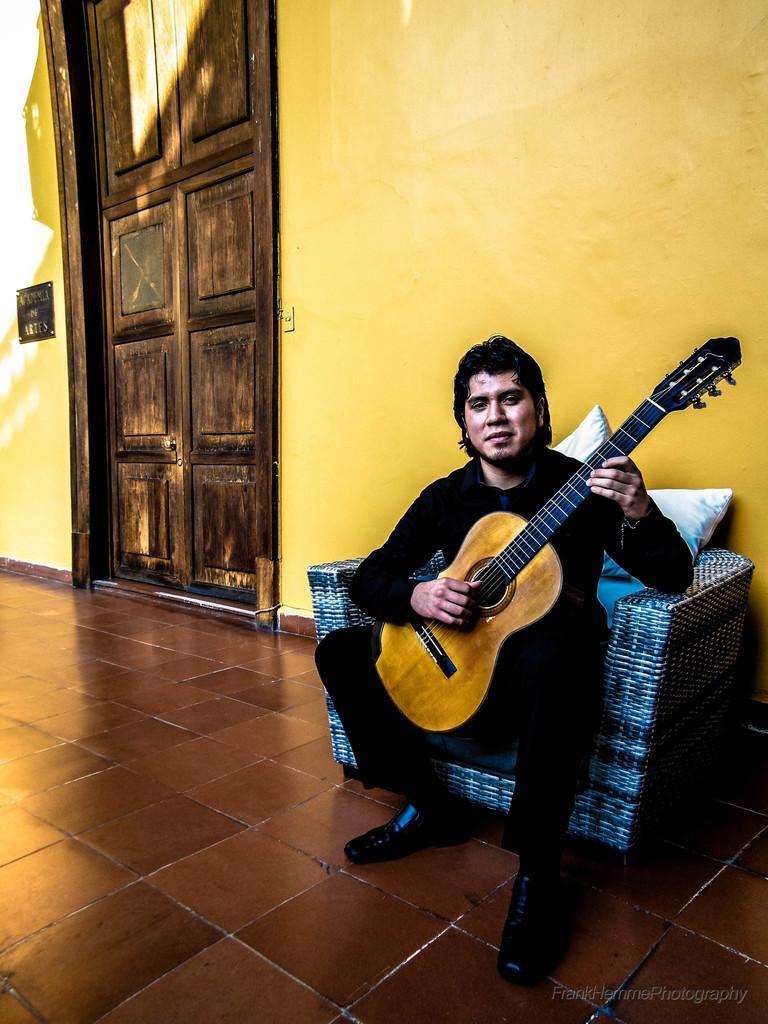Please provide a concise description of this image. In this image I see a man who is sitting on a couch and he is holding guitar and I see that he is wearing black dress. In the background I see the wall and the door over here. 